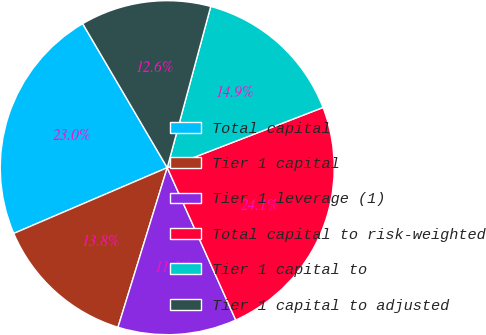<chart> <loc_0><loc_0><loc_500><loc_500><pie_chart><fcel>Total capital<fcel>Tier 1 capital<fcel>Tier 1 leverage (1)<fcel>Total capital to risk-weighted<fcel>Tier 1 capital to<fcel>Tier 1 capital to adjusted<nl><fcel>22.99%<fcel>13.79%<fcel>11.49%<fcel>24.14%<fcel>14.94%<fcel>12.64%<nl></chart> 